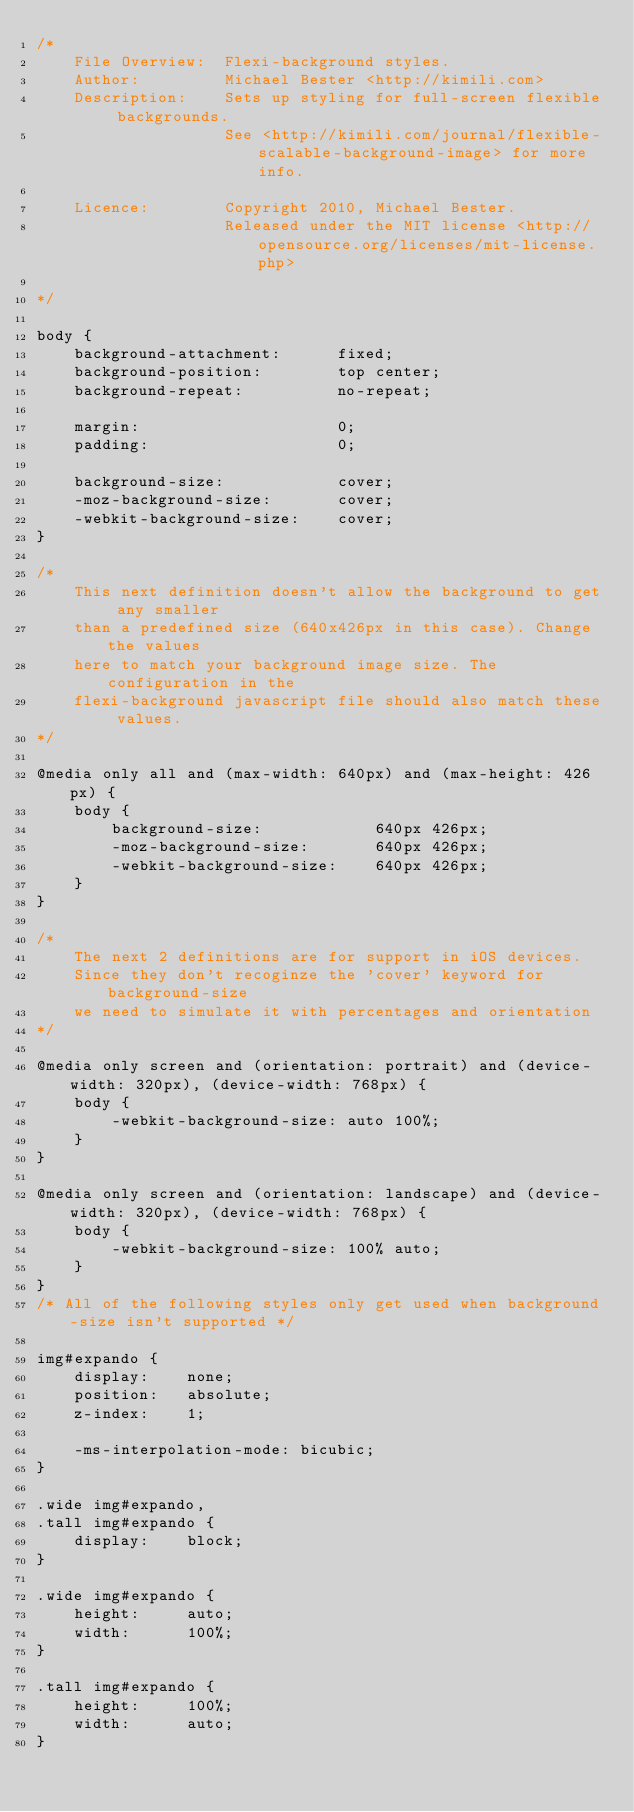<code> <loc_0><loc_0><loc_500><loc_500><_CSS_>/*
	File Overview:	Flexi-background styles.
	Author:			Michael Bester <http://kimili.com>
	Description:	Sets up styling for full-screen flexible backgrounds.
					See <http://kimili.com/journal/flexible-scalable-background-image> for more info.
	
	Licence:		Copyright 2010, Michael Bester.
					Released under the MIT license <http://opensource.org/licenses/mit-license.php>
	
*/

body { 
	background-attachment:		fixed; 
	background-position:		top center; 
	background-repeat:			no-repeat; 
	
	margin:						0;
	padding:					0;

	background-size:			cover;
	-moz-background-size:		cover;
	-webkit-background-size:	cover;
}

/*
	This next definition doesn't allow the background to get any smaller
	than a predefined size (640x426px in this case). Change the values
	here to match your background image size. The configuration in the
	flexi-background javascript file should also match these values.
*/

@media only all and (max-width: 640px) and (max-height: 426px) {
	body {		
		background-size:			640px 426px;
		-moz-background-size:		640px 426px;
		-webkit-background-size:	640px 426px;
	}
}

/*
	The next 2 definitions are for support in iOS devices.
 	Since they don't recoginze the 'cover' keyword for background-size
 	we need to simulate it with percentages and orientation
*/

@media only screen and (orientation: portrait) and (device-width: 320px), (device-width: 768px) {
	body {
		-webkit-background-size: auto 100%;
	}
}

@media only screen and (orientation: landscape) and (device-width: 320px), (device-width: 768px) {
	body {
		-webkit-background-size: 100% auto;
	}
}
/* All of the following styles only get used when background-size isn't supported */

img#expando { 
	display:	none;
	position:	absolute; 
	z-index:	1;
	 
	-ms-interpolation-mode: bicubic; 
} 

.wide img#expando, 
.tall img#expando { 
	display: 	block; 
} 

.wide img#expando { 
	height: 	auto;
	width: 		100%; 
} 

.tall img#expando { 
	height:		100%;
	width:		auto; 
}</code> 